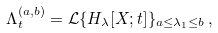Convert formula to latex. <formula><loc_0><loc_0><loc_500><loc_500>\Lambda ^ { ( a , b ) } _ { t } = { \mathcal { L } } \{ H _ { \lambda } [ X ; t ] \} _ { a \leq \lambda _ { 1 } \leq b } \, ,</formula> 